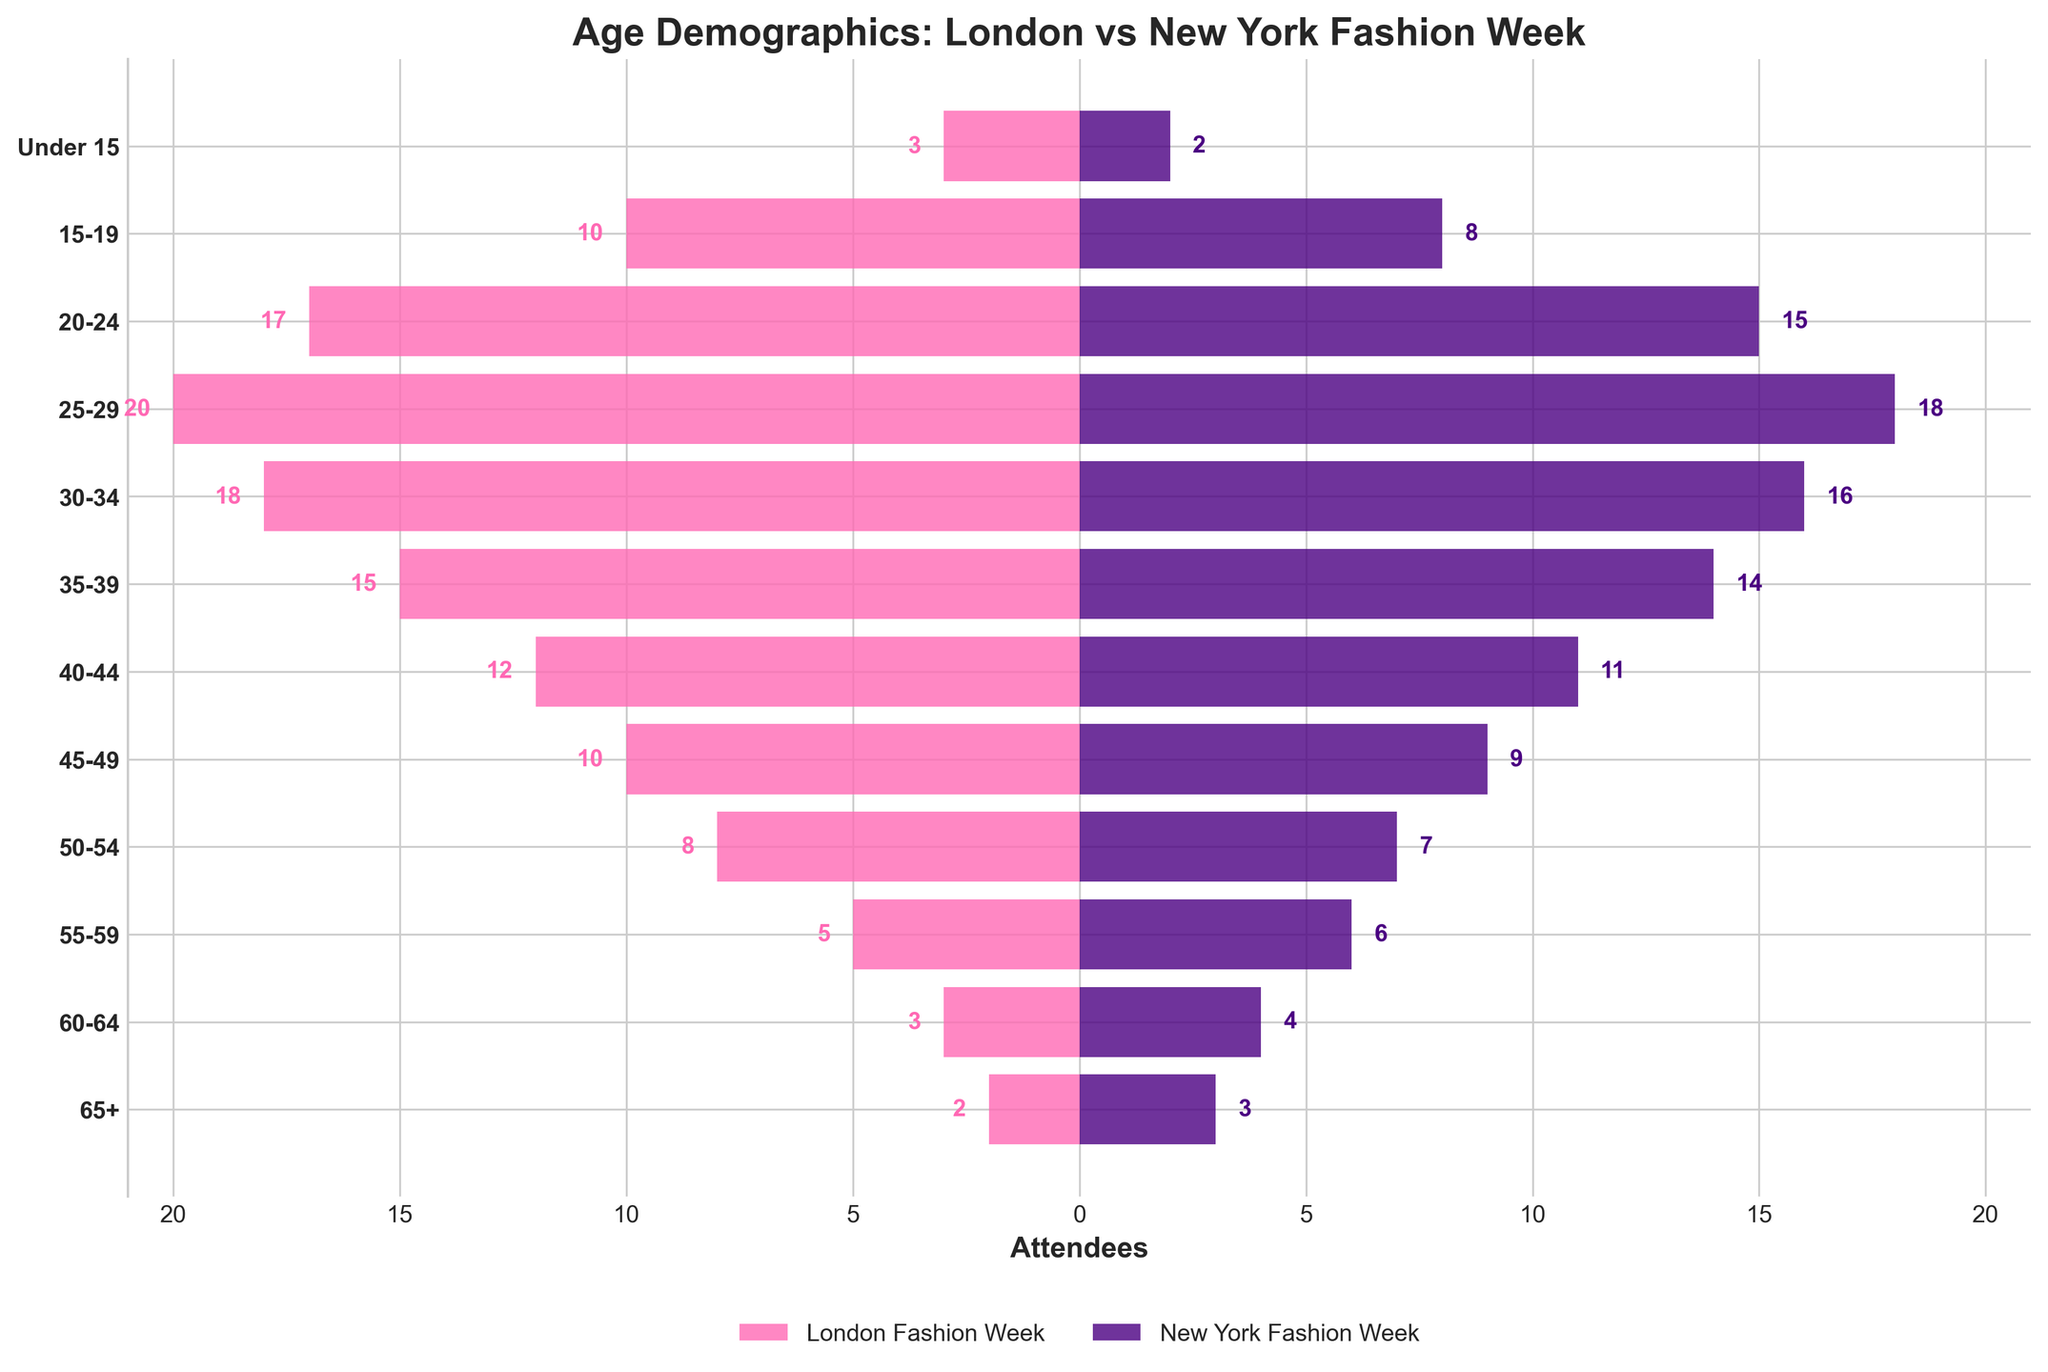What is the title of the plot? The title is usually at the top of the plot and provides a concise description of what the figure is about. In this case, it mentions both events and what is being compared.
Answer: Age Demographics: London vs New York Fashion Week What colors are used to represent London and New York Fashion Week attendees? The color categories are distinguishable visually from the bars horizontally extending from the central axis to respective directions. London is on the negative side and New York on the positive.
Answer: Pink for London and Purple for New York What is the age group with the highest number of attendees for London Fashion Week? The bars representing the number of attendees for each age group extend horizontally. The longest bar on the negative side indicates the highest count.
Answer: 25-29 Which age group has more attendees at New York Fashion Week compared to London Fashion Week? By comparing the lengths of the bars extending to the left and right for each age group, we identify which rightward bar is longer than its counterpart.
Answer: 65+ How many total attendees are there for the age groups 30-34 and 35-39 at London Fashion Week? Look at the length of the corresponding bars on the negative side, then sum the values for these age groups (18 + 15).
Answer: 33 What is the difference in the number of attendees between the age group 50-54 for London and New York Fashion Week? Compare the lengths of the bars for the age group 50-54 on both the negative (London) and positive (New York) sides. Subtract the shorter bar from the longer one.
Answer: 1 Which age group has an equal number of attendees at both fashion weeks? Check if any bars extend equally to both sides for any age group.
Answer: Under 15 What is the total number of attendees for the 20-24 age group at both fashion weeks combined? Add the values of the horizontal bars extending left (London) and right (New York) for the age group 20-24 (17 + 15).
Answer: 32 What are the youngest and oldest age groups listed in the plot? The y-axis labels range from youngest to oldest. The labels at the bottom and top of the y-axis indicate the age extremes.
Answer: Under 15, 65+ In which age group does London Fashion Week see a notably higher number of attendees than New York Fashion Week? Compare the lengths of the bars for each age group. Identify where the leftward bar (London) extends much further than the rightward bar (New York).
Answer: 25-29 